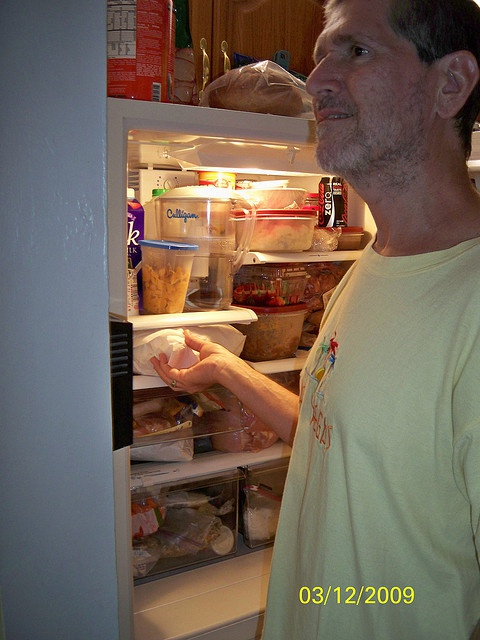Describe the objects in this image and their specific colors. I can see people in black, gray, and maroon tones and refrigerator in black, maroon, and gray tones in this image. 